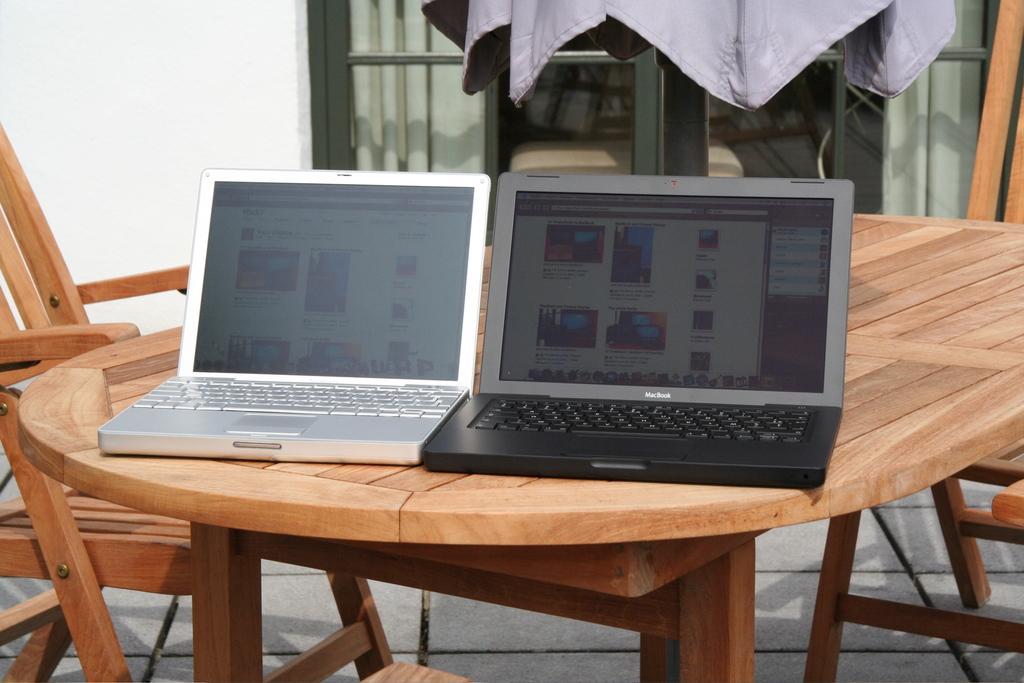In one or two sentences, can you explain what this image depicts? This image consists of a table, chair and on the table there are two laptops ,one of them is in silver colour and the other one is in black colour. There is a jacket on the top. 